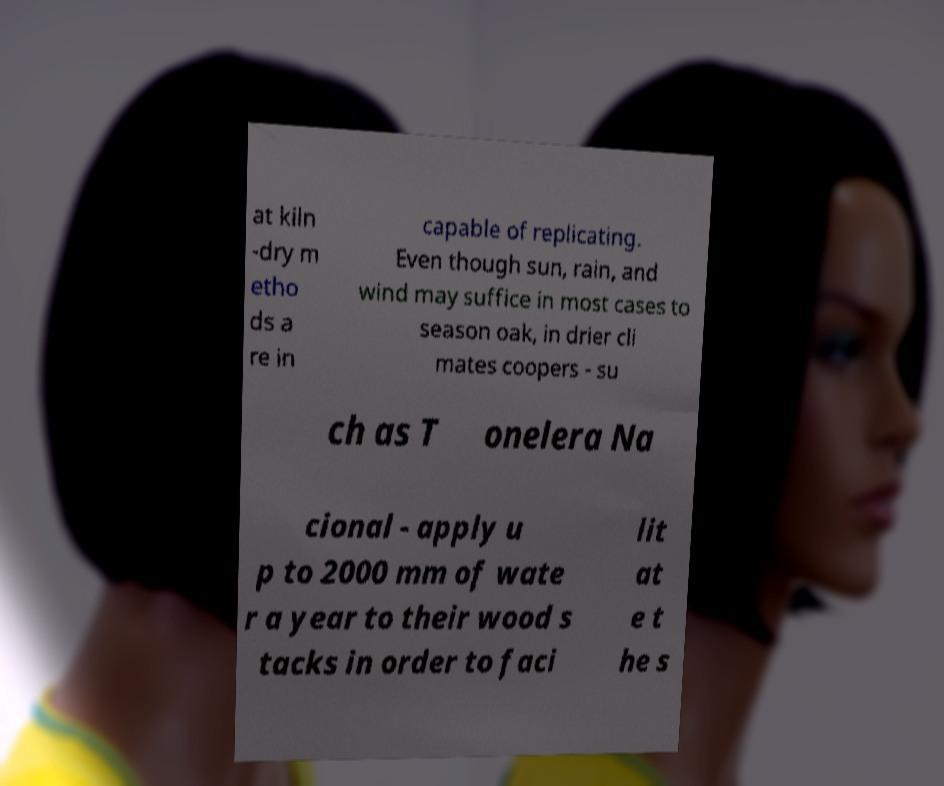Could you extract and type out the text from this image? at kiln -dry m etho ds a re in capable of replicating. Even though sun, rain, and wind may suffice in most cases to season oak, in drier cli mates coopers - su ch as T onelera Na cional - apply u p to 2000 mm of wate r a year to their wood s tacks in order to faci lit at e t he s 